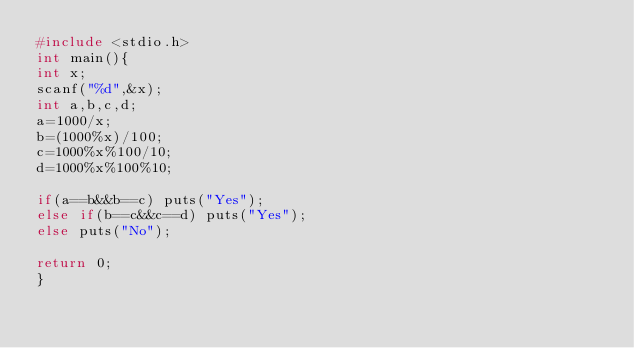<code> <loc_0><loc_0><loc_500><loc_500><_C_>#include <stdio.h>
int main(){
int x;
scanf("%d",&x);
int a,b,c,d;
a=1000/x;
b=(1000%x)/100;
c=1000%x%100/10;
d=1000%x%100%10;

if(a==b&&b==c) puts("Yes");
else if(b==c&&c==d) puts("Yes");
else puts("No");

return 0;
}</code> 